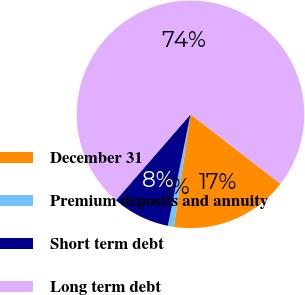Convert chart. <chart><loc_0><loc_0><loc_500><loc_500><pie_chart><fcel>December 31<fcel>Premium deposits and annuity<fcel>Short term debt<fcel>Long term debt<nl><fcel>16.86%<fcel>0.87%<fcel>8.19%<fcel>74.07%<nl></chart> 